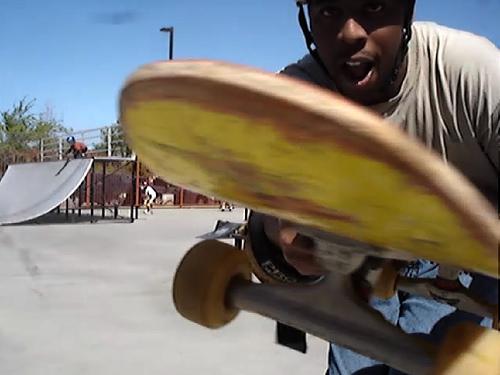Is he happy?
Be succinct. Yes. How many ramps are visible?
Be succinct. 1. What is the blurred object near the camera?
Be succinct. Skateboard. 